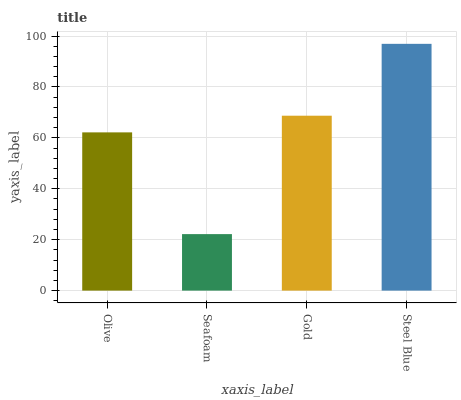Is Seafoam the minimum?
Answer yes or no. Yes. Is Steel Blue the maximum?
Answer yes or no. Yes. Is Gold the minimum?
Answer yes or no. No. Is Gold the maximum?
Answer yes or no. No. Is Gold greater than Seafoam?
Answer yes or no. Yes. Is Seafoam less than Gold?
Answer yes or no. Yes. Is Seafoam greater than Gold?
Answer yes or no. No. Is Gold less than Seafoam?
Answer yes or no. No. Is Gold the high median?
Answer yes or no. Yes. Is Olive the low median?
Answer yes or no. Yes. Is Olive the high median?
Answer yes or no. No. Is Gold the low median?
Answer yes or no. No. 